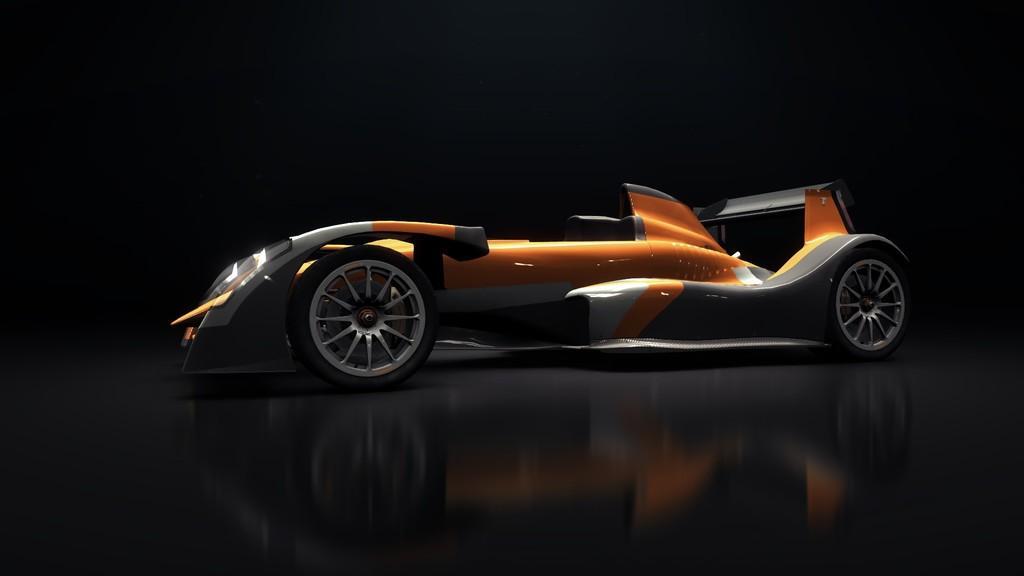Can you describe this image briefly? In the center of this picture we can see a vehicle seems to be a go-kart and the background of the image is black in color. 